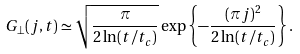Convert formula to latex. <formula><loc_0><loc_0><loc_500><loc_500>G _ { \perp } ( j , t ) \simeq \sqrt { \frac { \pi } { 2 \ln ( t / t _ { c } ) } } \exp \left \{ - \frac { ( \pi j ) ^ { 2 } } { 2 \ln ( t / t _ { c } ) } \right \} .</formula> 